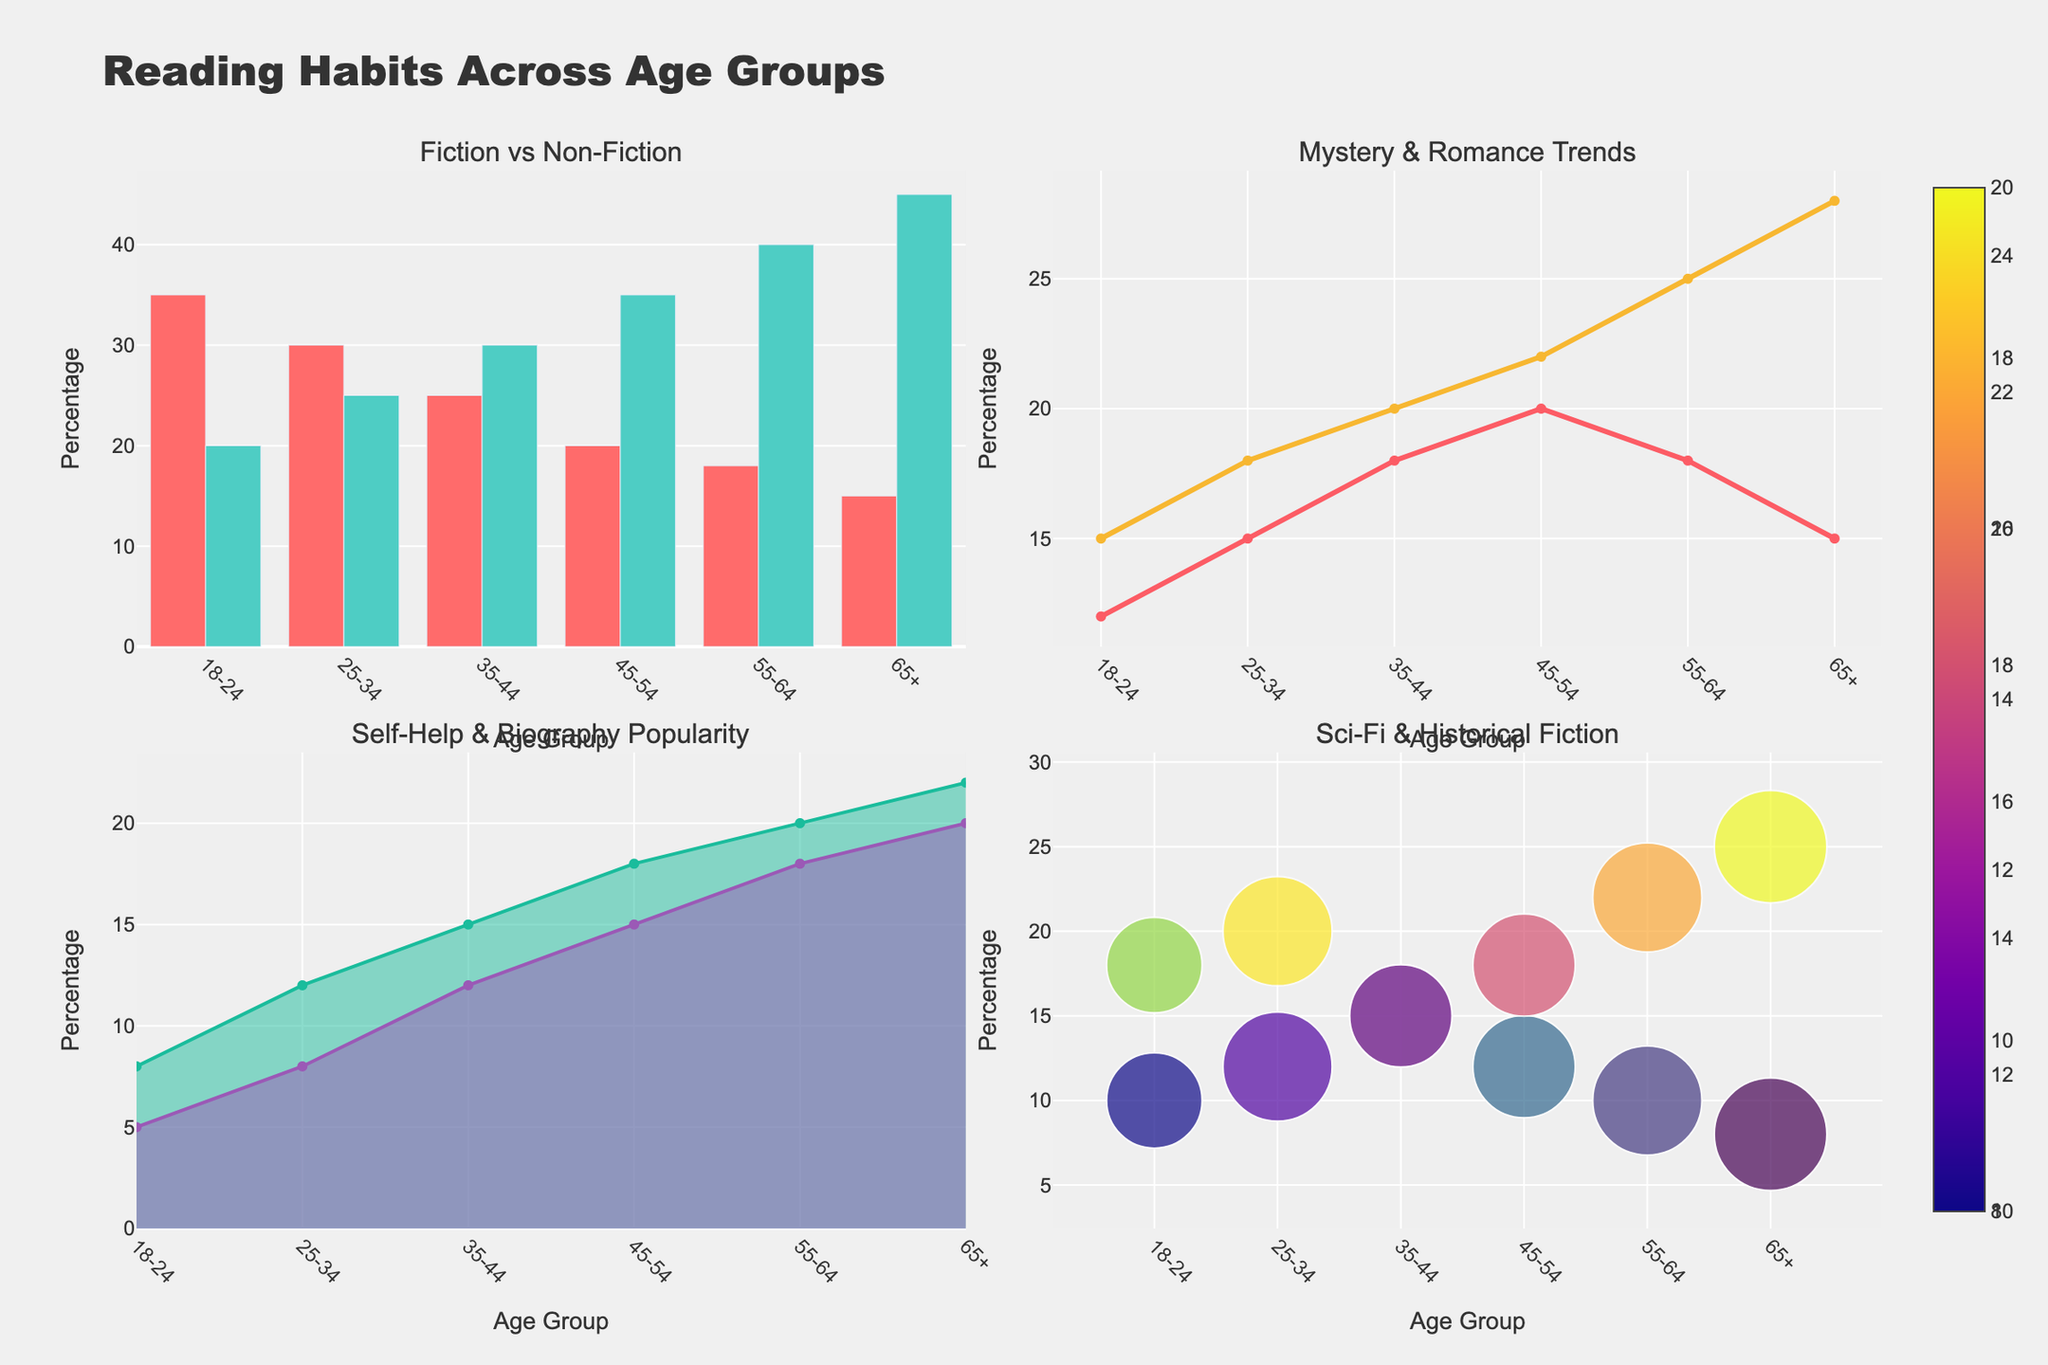Which age group reads the most Fiction books? By examining the bar heights for Fiction in the "Fiction vs Non-Fiction" subplot, we can see the highest bar corresponds to the 18-24 age group with 35.
Answer: 18-24 How do the popularity trends for Mystery and Romance compare over different age groups? Looking at the "Mystery & Romance Trends" subplot, we observe that both genres increase from 18-24 age group to the 65+ age group, peaking at 65+ for Mystery and 45-54 for Romance.
Answer: Both increase with age, Mystery peaks at 65+, Romance peaks at 45-54 What is the difference in popularity between Self-Help and Biography for the 45-54 age group? Refer to the "Self-Help & Biography Popularity" subplot; the 45-54 age group's Self-Help and Biography values are 18 and 15 respectively. The difference is 18 - 15 = 3.
Answer: 3 Which genre has the highest percentage in the 65+ age group? Look across all subplots and data points for the 65+ age group. Non-Fiction is the highest with 45%.
Answer: Non-Fiction In the Sci-Fi & Historical Fiction subplot, which age group shows the highest popularity for Historical Fiction? Observe the "Sci-Fi & Historical Fiction" subplot; the largest bubble for Historical Fiction corresponds to the 65+ age group.
Answer: 65+ Between the 25-34 and 35-44 age groups, which age group shows a higher preference for Non-Fiction books? In the "Fiction vs Non-Fiction" subplot, compare the Non-Fiction bars for these age groups. The 35-44 age group has a higher preference with 30 versus 25 for the 25-34 group.
Answer: 35-44 What trend do we see for the popularity of Science Fiction as age increases? From the "Sci-Fi & Historical Fiction" subplot, it is evident that the size of the Science Fiction markers decreases as age increases, showing a declining trend.
Answer: Declining Is there a genre where the 18-24 age group has the lowest percentage, compared to other age groups? Look at all subplots and compare values for the 18-24 age group across genres. They have the lowest percentage in Biography with 5.
Answer: Biography What is the combined percentage of Mystery and Romance books read by the 35-44 age group? In the "Mystery & Romance Trends" subplot, the percentages for Mystery and Romance in the 35-44 age group are 20 and 18 respectively. The combined percentage is 20 + 18 = 38.
Answer: 38 How does the preference for Historical Fiction vary across age groups? Referring to "Sci-Fi & Historical Fiction" subplot, the size of the Historical Fiction markers and corresponding y-values indicate it increases with age, highest at 65+.
Answer: Increases with age, highest at 65+ 